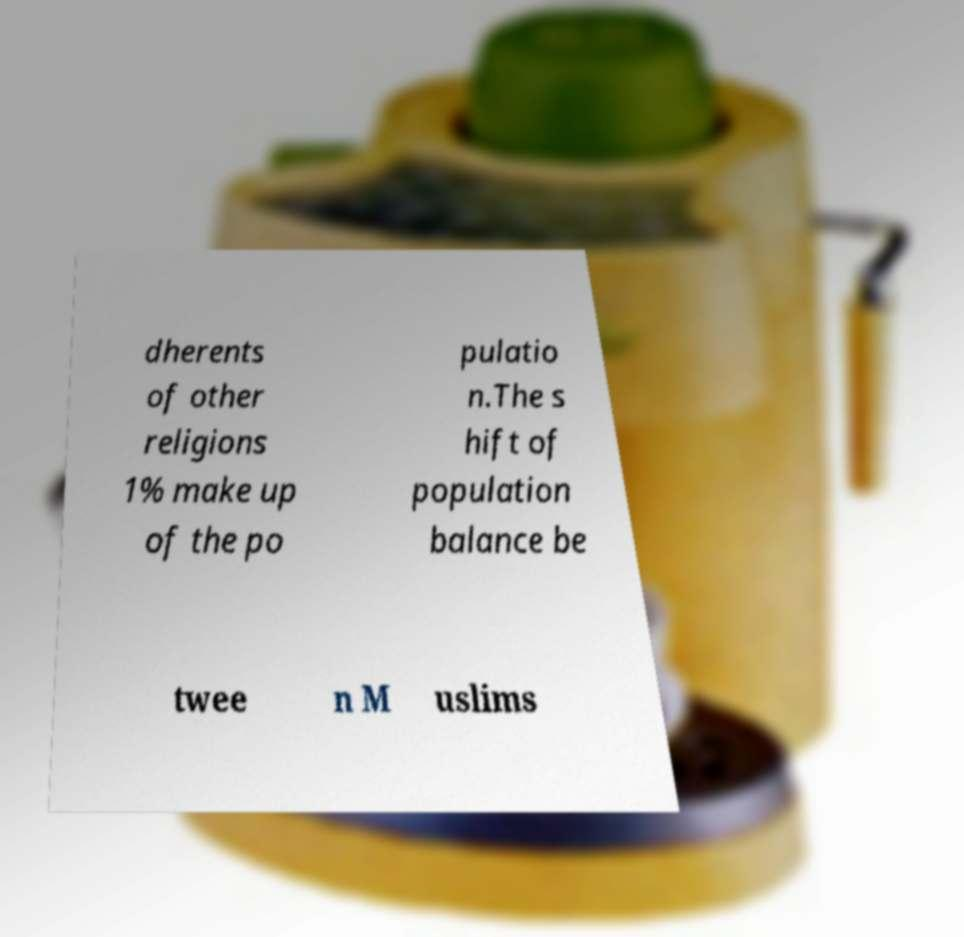For documentation purposes, I need the text within this image transcribed. Could you provide that? dherents of other religions 1% make up of the po pulatio n.The s hift of population balance be twee n M uslims 